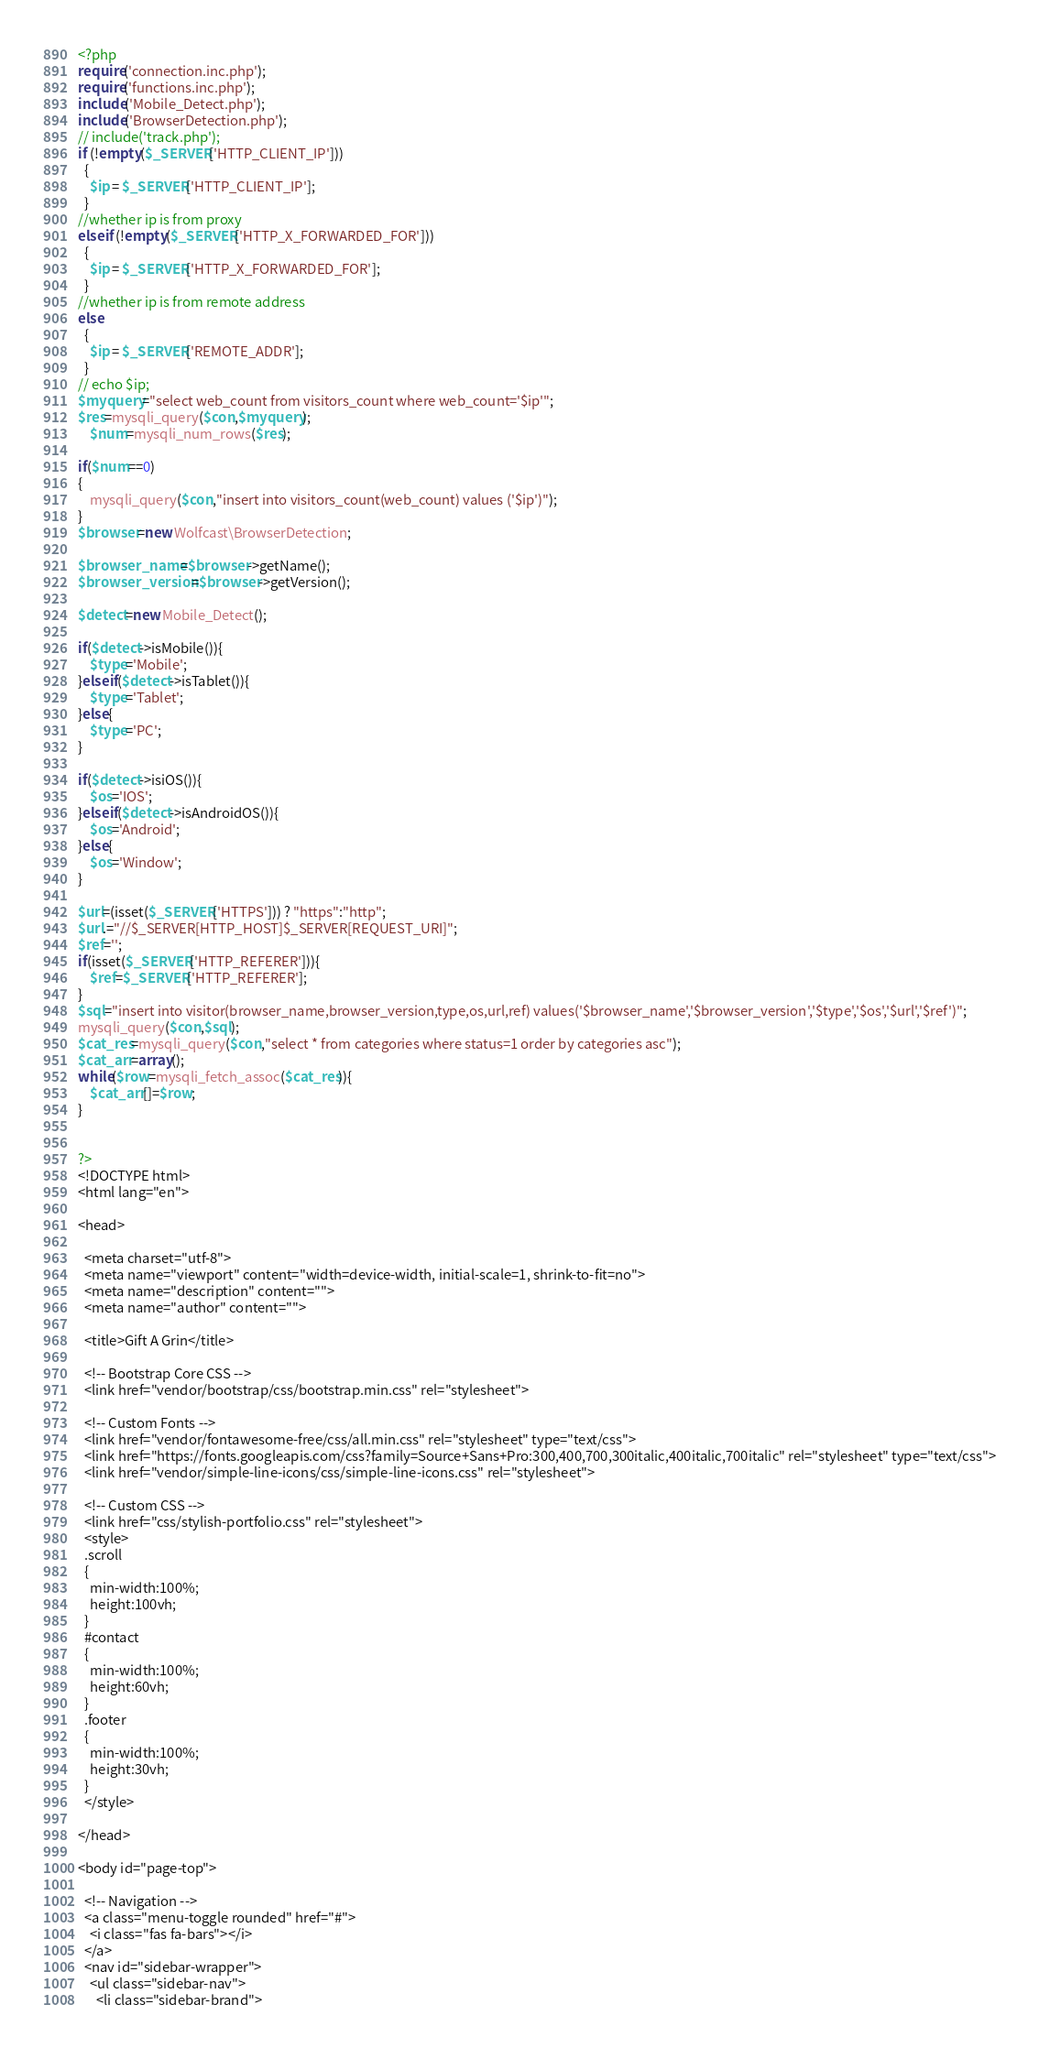Convert code to text. <code><loc_0><loc_0><loc_500><loc_500><_PHP_><?php
require('connection.inc.php');
require('functions.inc.php');
include('Mobile_Detect.php');
include('BrowserDetection.php');
// include('track.php');
if (!empty($_SERVER['HTTP_CLIENT_IP']))   
  {
    $ip = $_SERVER['HTTP_CLIENT_IP'];
  }
//whether ip is from proxy
elseif (!empty($_SERVER['HTTP_X_FORWARDED_FOR']))  
  {
    $ip = $_SERVER['HTTP_X_FORWARDED_FOR'];
  }
//whether ip is from remote address
else
  {
    $ip = $_SERVER['REMOTE_ADDR'];
  }
// echo $ip;
$myquery="select web_count from visitors_count where web_count='$ip'";
$res=mysqli_query($con,$myquery);
    $num=mysqli_num_rows($res);
    
if($num==0)
{
    mysqli_query($con,"insert into visitors_count(web_count) values ('$ip')");
}
$browser=new Wolfcast\BrowserDetection;

$browser_name=$browser->getName();
$browser_version=$browser->getVersion();

$detect=new Mobile_Detect();

if($detect->isMobile()){
	$type='Mobile';
}elseif($detect->isTablet()){
	$type='Tablet';
}else{
	$type='PC';
}

if($detect->isiOS()){
	$os='IOS';
}elseif($detect->isAndroidOS()){
	$os='Android';
}else{
	$os='Window';
}

$url=(isset($_SERVER['HTTPS'])) ? "https":"http";
$url.="//$_SERVER[HTTP_HOST]$_SERVER[REQUEST_URI]";
$ref='';
if(isset($_SERVER['HTTP_REFERER'])){
	$ref=$_SERVER['HTTP_REFERER'];
}
$sql="insert into visitor(browser_name,browser_version,type,os,url,ref) values('$browser_name','$browser_version','$type','$os','$url','$ref')";
mysqli_query($con,$sql);
$cat_res=mysqli_query($con,"select * from categories where status=1 order by categories asc");
$cat_arr=array();
while($row=mysqli_fetch_assoc($cat_res)){
	$cat_arr[]=$row;	
}


?>
<!DOCTYPE html>
<html lang="en">

<head>

  <meta charset="utf-8">
  <meta name="viewport" content="width=device-width, initial-scale=1, shrink-to-fit=no">
  <meta name="description" content="">
  <meta name="author" content="">

  <title>Gift A Grin</title>

  <!-- Bootstrap Core CSS -->
  <link href="vendor/bootstrap/css/bootstrap.min.css" rel="stylesheet">

  <!-- Custom Fonts -->
  <link href="vendor/fontawesome-free/css/all.min.css" rel="stylesheet" type="text/css">
  <link href="https://fonts.googleapis.com/css?family=Source+Sans+Pro:300,400,700,300italic,400italic,700italic" rel="stylesheet" type="text/css">
  <link href="vendor/simple-line-icons/css/simple-line-icons.css" rel="stylesheet">

  <!-- Custom CSS -->
  <link href="css/stylish-portfolio.css" rel="stylesheet">
  <style>
  .scroll
  {
    min-width:100%;
    height:100vh;
  }
  #contact
  {
    min-width:100%;
    height:60vh;
  }
  .footer
  {
    min-width:100%;
    height:30vh;
  }
  </style>

</head>

<body id="page-top">

  <!-- Navigation -->
  <a class="menu-toggle rounded" href="#">
    <i class="fas fa-bars"></i>
  </a>
  <nav id="sidebar-wrapper">
    <ul class="sidebar-nav">
      <li class="sidebar-brand"></code> 